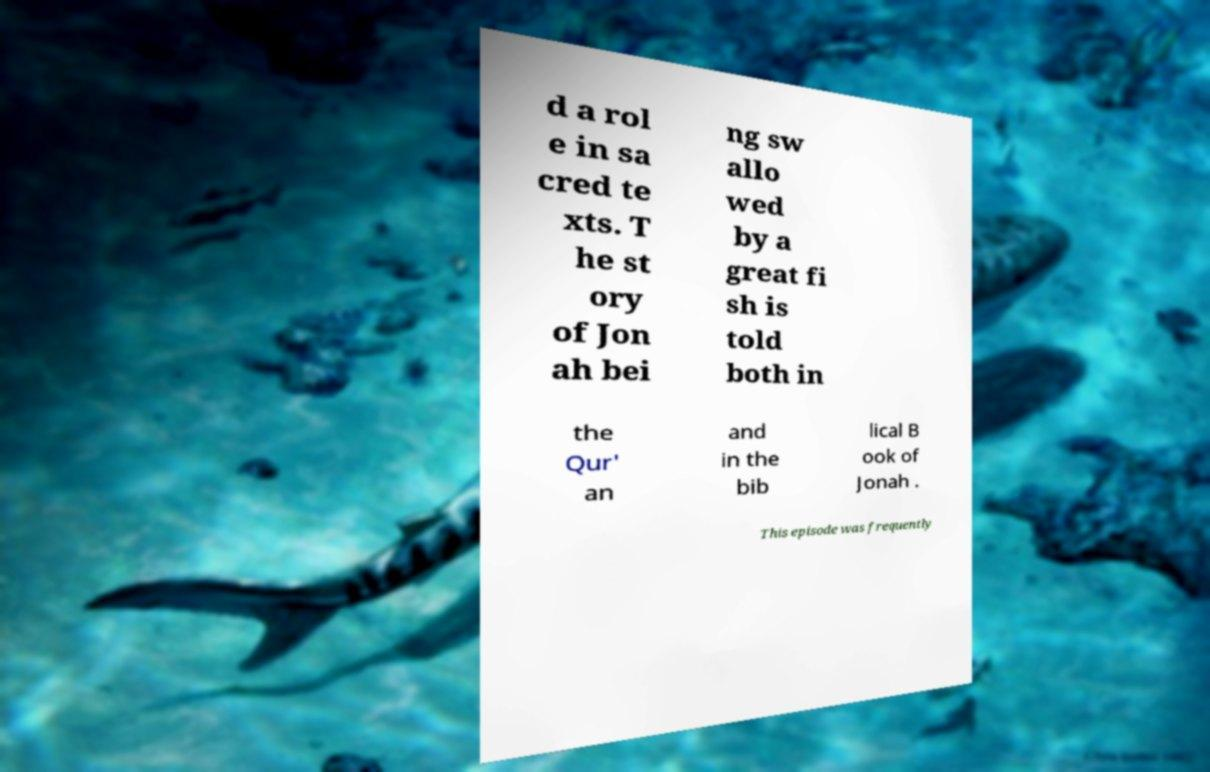Could you extract and type out the text from this image? d a rol e in sa cred te xts. T he st ory of Jon ah bei ng sw allo wed by a great fi sh is told both in the Qur' an and in the bib lical B ook of Jonah . This episode was frequently 